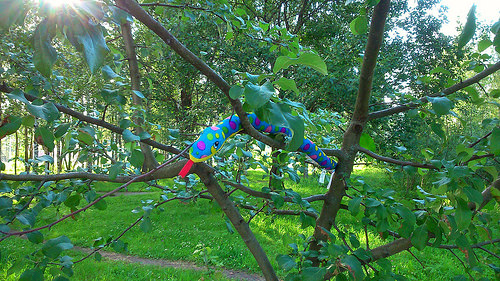<image>
Is the snake in the grass? No. The snake is not contained within the grass. These objects have a different spatial relationship. 